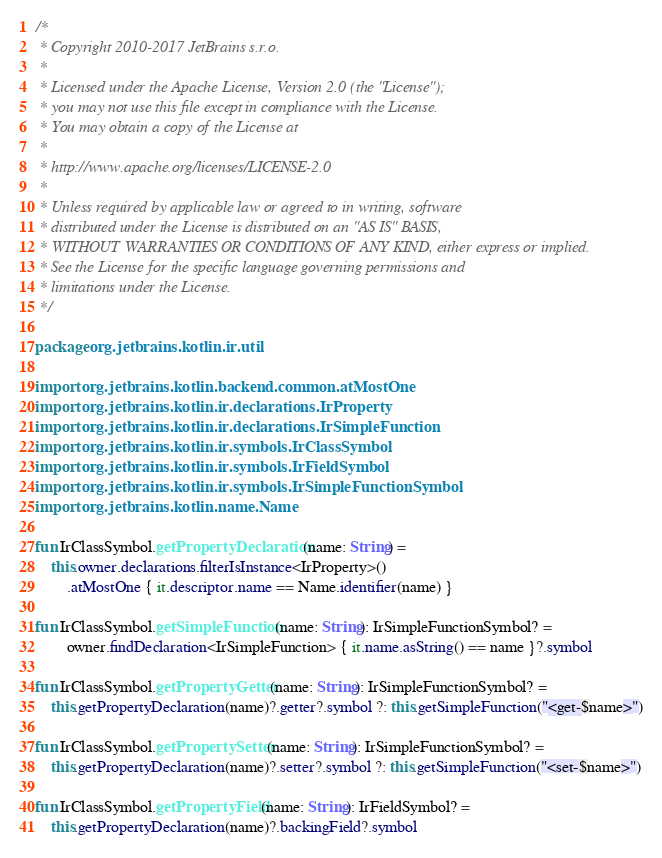Convert code to text. <code><loc_0><loc_0><loc_500><loc_500><_Kotlin_>/*
 * Copyright 2010-2017 JetBrains s.r.o.
 *
 * Licensed under the Apache License, Version 2.0 (the "License");
 * you may not use this file except in compliance with the License.
 * You may obtain a copy of the License at
 *
 * http://www.apache.org/licenses/LICENSE-2.0
 *
 * Unless required by applicable law or agreed to in writing, software
 * distributed under the License is distributed on an "AS IS" BASIS,
 * WITHOUT WARRANTIES OR CONDITIONS OF ANY KIND, either express or implied.
 * See the License for the specific language governing permissions and
 * limitations under the License.
 */

package org.jetbrains.kotlin.ir.util

import org.jetbrains.kotlin.backend.common.atMostOne
import org.jetbrains.kotlin.ir.declarations.IrProperty
import org.jetbrains.kotlin.ir.declarations.IrSimpleFunction
import org.jetbrains.kotlin.ir.symbols.IrClassSymbol
import org.jetbrains.kotlin.ir.symbols.IrFieldSymbol
import org.jetbrains.kotlin.ir.symbols.IrSimpleFunctionSymbol
import org.jetbrains.kotlin.name.Name

fun IrClassSymbol.getPropertyDeclaration(name: String) =
    this.owner.declarations.filterIsInstance<IrProperty>()
        .atMostOne { it.descriptor.name == Name.identifier(name) }

fun IrClassSymbol.getSimpleFunction(name: String): IrSimpleFunctionSymbol? =
        owner.findDeclaration<IrSimpleFunction> { it.name.asString() == name }?.symbol

fun IrClassSymbol.getPropertyGetter(name: String): IrSimpleFunctionSymbol? =
    this.getPropertyDeclaration(name)?.getter?.symbol ?: this.getSimpleFunction("<get-$name>")

fun IrClassSymbol.getPropertySetter(name: String): IrSimpleFunctionSymbol? =
    this.getPropertyDeclaration(name)?.setter?.symbol ?: this.getSimpleFunction("<set-$name>")

fun IrClassSymbol.getPropertyField(name: String): IrFieldSymbol? =
    this.getPropertyDeclaration(name)?.backingField?.symbol
</code> 